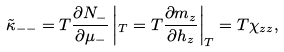<formula> <loc_0><loc_0><loc_500><loc_500>\tilde { \kappa } _ { - - } = T \frac { \partial N _ { - } } { \partial \mu _ { - } } \left | _ { T } = T \frac { \partial m _ { z } } { \partial h _ { z } } \right | _ { T } = T \chi _ { z z } ,</formula> 